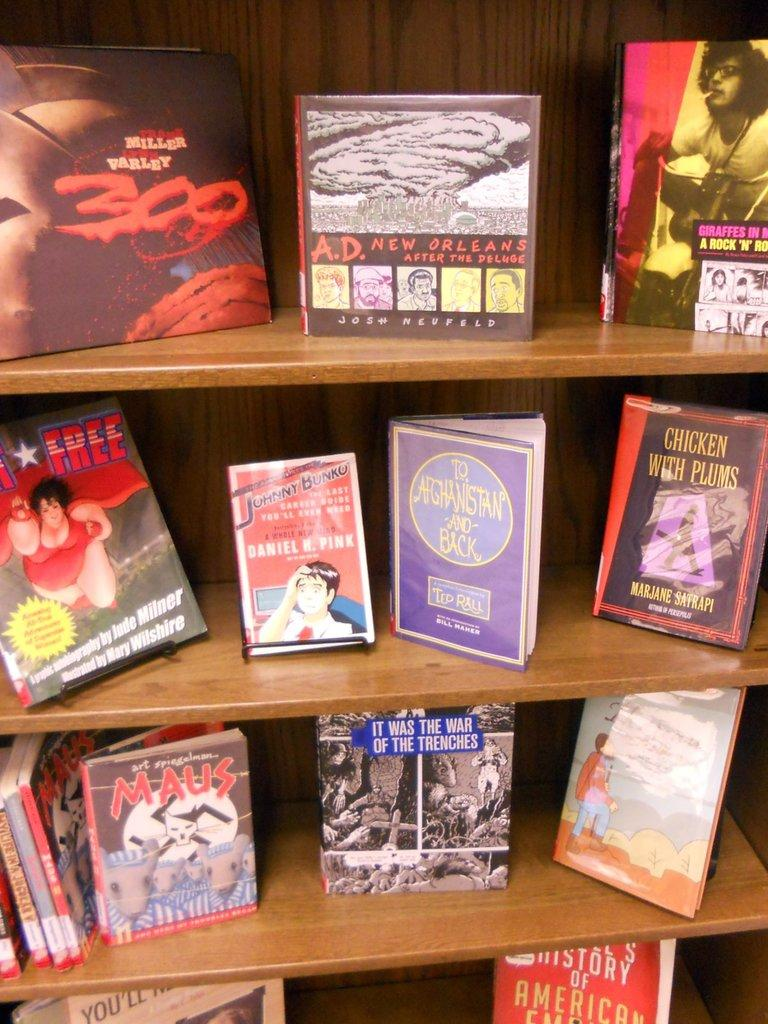<image>
Share a concise interpretation of the image provided. A book case has books on every shelf including A.D. New Orleans by Josh Neufeld. 